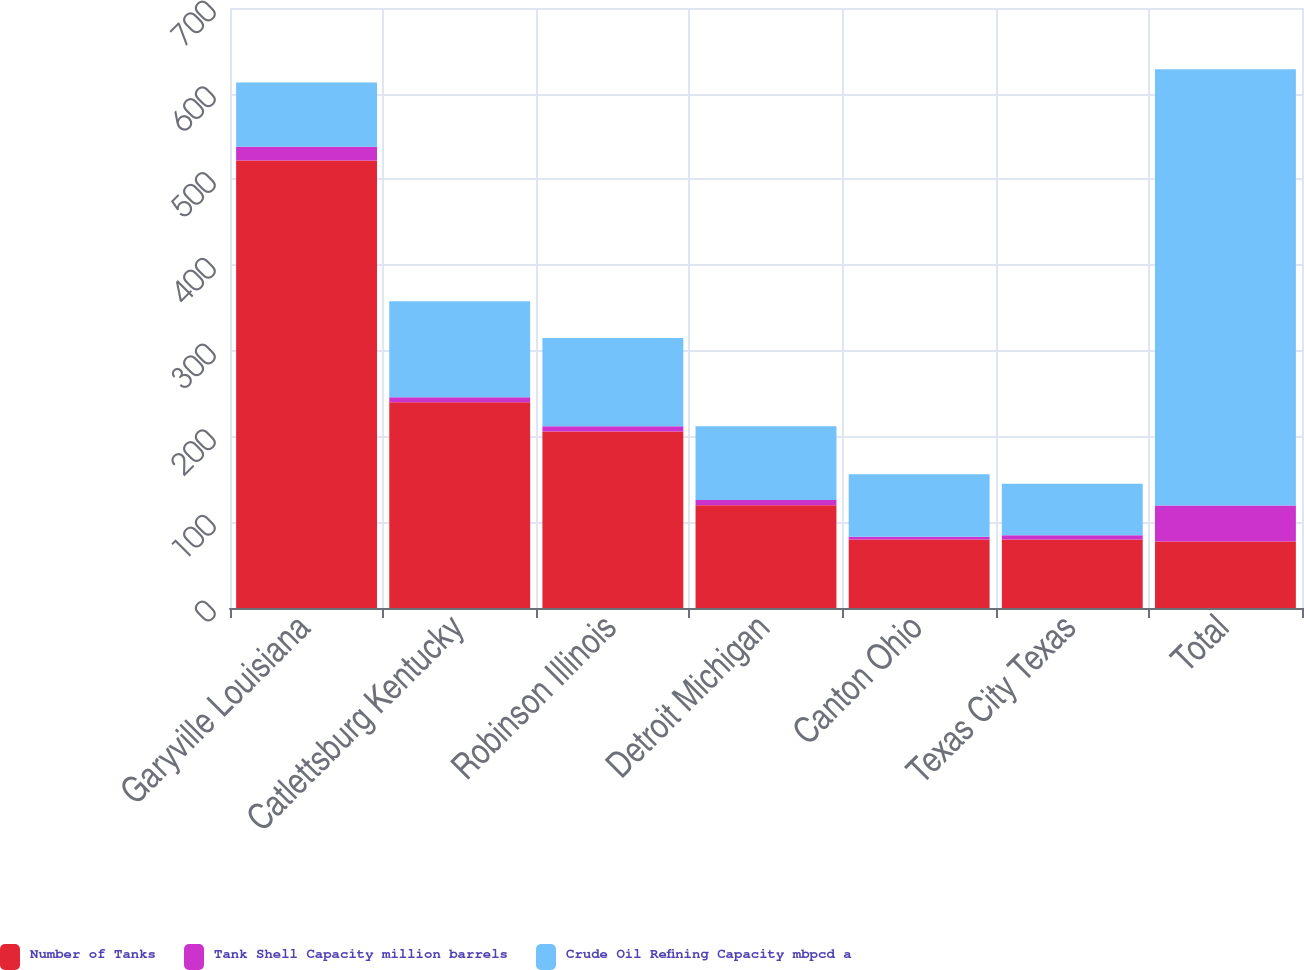Convert chart to OTSL. <chart><loc_0><loc_0><loc_500><loc_500><stacked_bar_chart><ecel><fcel>Garyville Louisiana<fcel>Catlettsburg Kentucky<fcel>Robinson Illinois<fcel>Detroit Michigan<fcel>Canton Ohio<fcel>Texas City Texas<fcel>Total<nl><fcel>Number of Tanks<fcel>522<fcel>240<fcel>206<fcel>120<fcel>80<fcel>80<fcel>77.5<nl><fcel>Tank Shell Capacity million barrels<fcel>16<fcel>6<fcel>6<fcel>6<fcel>3<fcel>5<fcel>42<nl><fcel>Crude Oil Refining Capacity mbpcd a<fcel>75<fcel>112<fcel>103<fcel>86<fcel>73<fcel>60<fcel>509<nl></chart> 